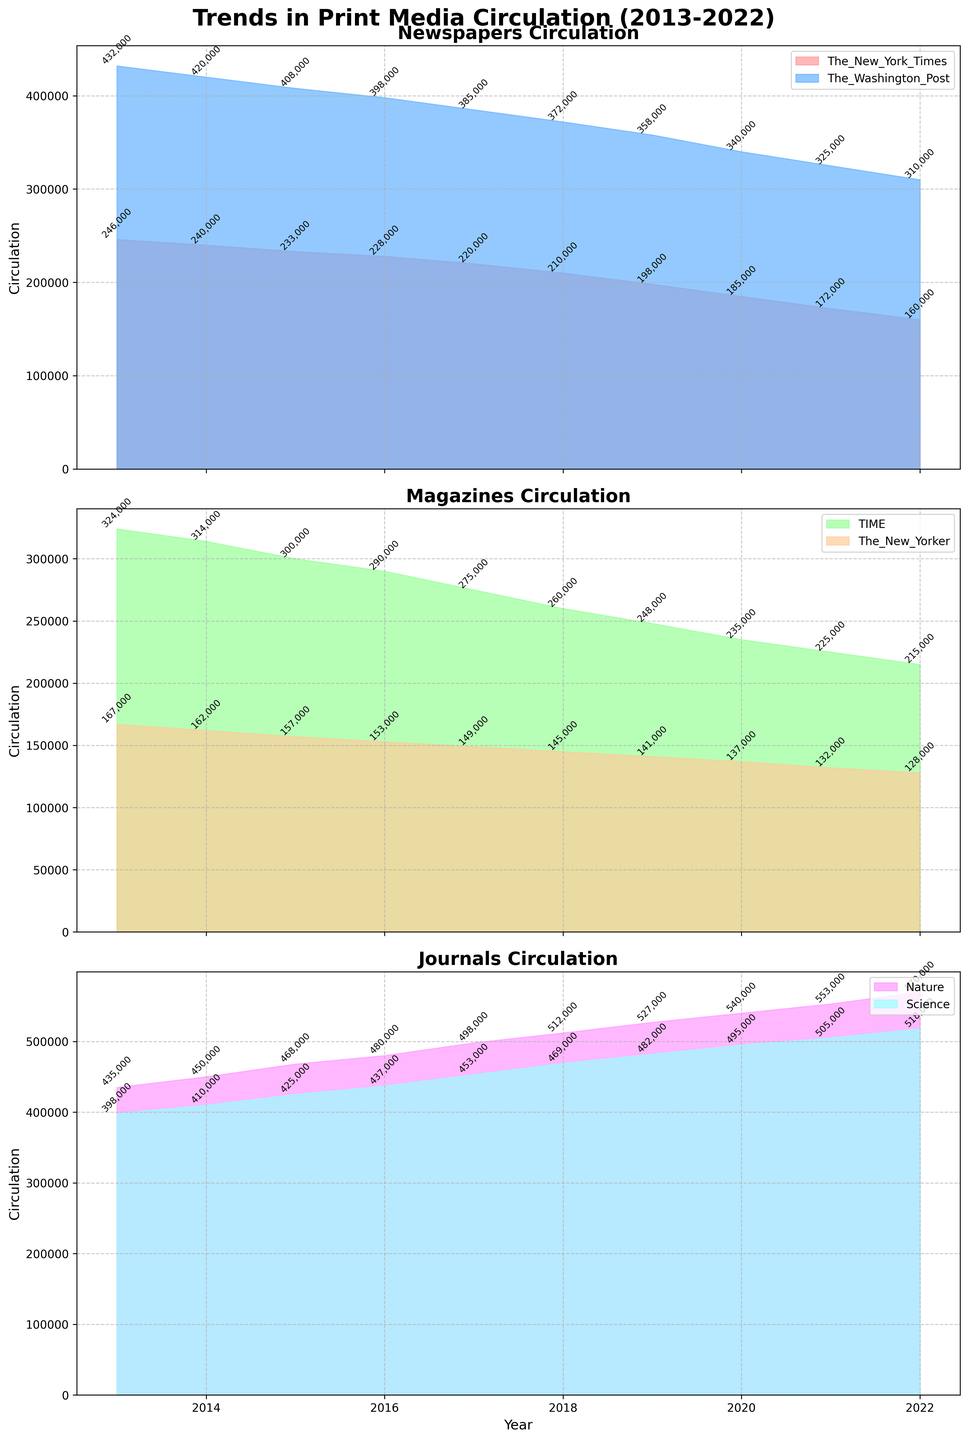How did the circulation of The Washington Post change from 2013 to 2022? The circulation of The Washington Post decreased from 432,000 in 2013 to 310,000 in 2022. This can be observed from the area plot for `Newspapers`, which shows a decreasing trend in the area for The Washington Post between these years.
Answer: It decreased What was the total circulation for the print media types (Newspapers, Magazines, Journals) in 2019? To find the total circulation for 2019, sum the individual values from each category for that year: Newspapers (`The New York Times` 198,000 + `The Washington Post` 358,000), Magazines (`TIME` 248,000 + `The New Yorker` 141,000), and Journals (`Nature` 527,000 + `Science` 482,000). Calculation: 198,000 + 358,000 + 248,000 + 141,000 + 527,000 + 482,000 = 1,954,000.
Answer: 1,954,000 Which newspaper showed a steadier decline in circulation over the period, The New York Times or The Washington Post? By comparing the area under the `The New York Times` and `The Washington Post` in the `Newspapers` subplot, both show declines, but The New York Times exhibits a more consistent, slightly smoother downward trend year by year compared to The Washington Post.
Answer: The New York Times What is the average circulation of Nature journal over the whole period? Sum the circulation values of Nature journal from 2013 to 2022 (435,000 + 450,000 + 468,000 + 480,000 + 498,000 + 512,000 + 527,000 + 540,000 + 553,000 + 570,000) and divide by the number of years (10). The calculation is: (435,000 + 450,000 + 468,000 + 480,000 + 498,000 + 512,000 + 527,000 + 540,000 + 553,000 + 570,000)/10 = 493,300.
Answer: 493,300 In which year did The New York Times have the equal circulation as The Washington Post had in 2020? The circulation of The Washington Post in 2020 was 340,000. The corresponding year when The New York Times had approximately the same value was 2017, which had a circulation value of 220,000. Thus, the New York Times did not reach equal circulation levels as The Washington Post had in 2020 during the decade span.
Answer: No such year Which magazine had a higher circulation in 2022, and by how much did it surpass the other? In 2022, TIME had a higher circulation with 215,000 compared to The New Yorker with 128,000. The difference is calculated as 215,000 - 128,000 = 87,000. This can easily be seen by comparing the area heights for each magazine in 2022 in the `Magazines` subplot.
Answer: TIME by 87,000 